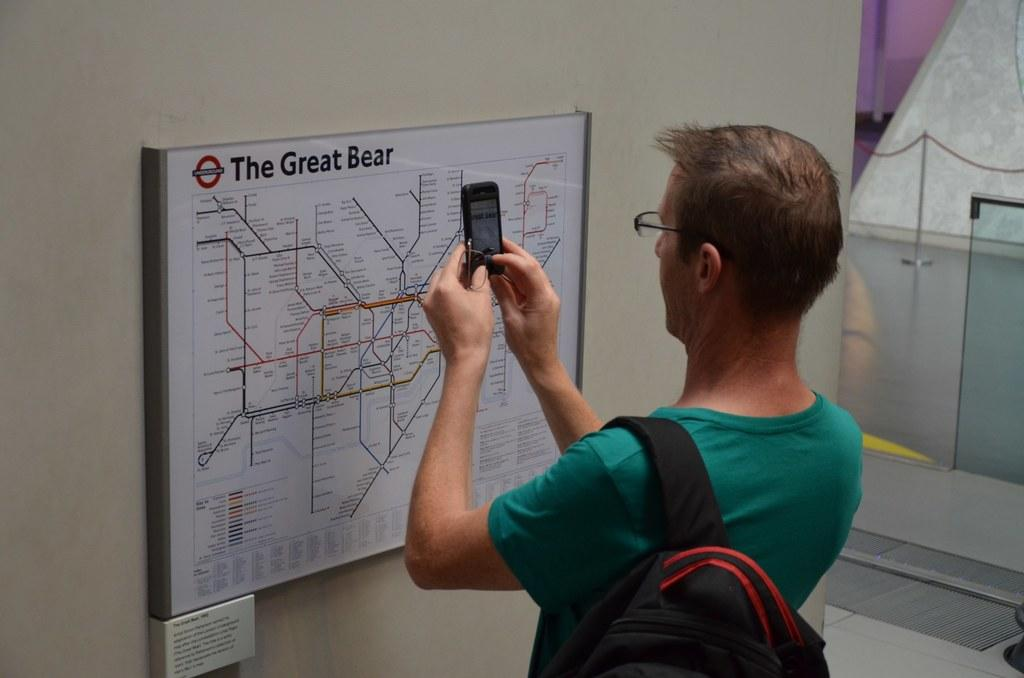<image>
Present a compact description of the photo's key features. a man taking a photo of the great bear 